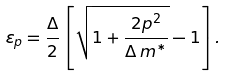Convert formula to latex. <formula><loc_0><loc_0><loc_500><loc_500>\varepsilon _ { p } = \frac { \Delta } { 2 } \left [ \sqrt { 1 + \frac { 2 p ^ { 2 } } { \Delta \, m ^ { * } } } - 1 \right ] .</formula> 